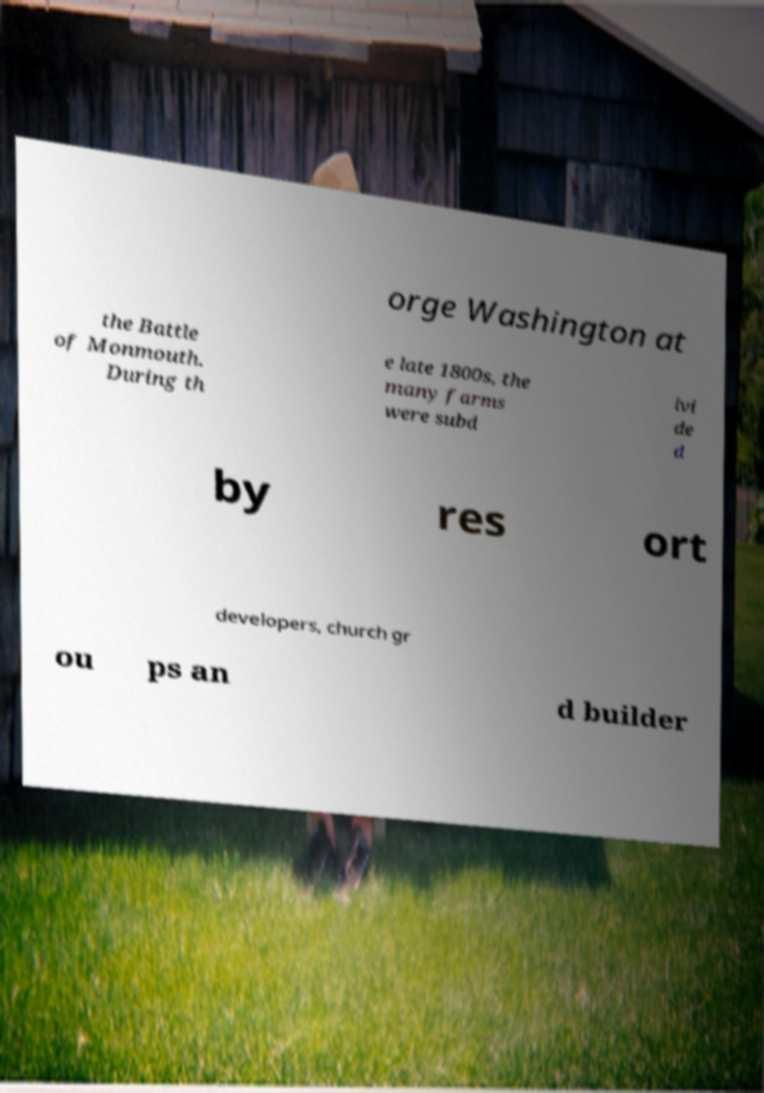Please read and relay the text visible in this image. What does it say? orge Washington at the Battle of Monmouth. During th e late 1800s, the many farms were subd ivi de d by res ort developers, church gr ou ps an d builder 